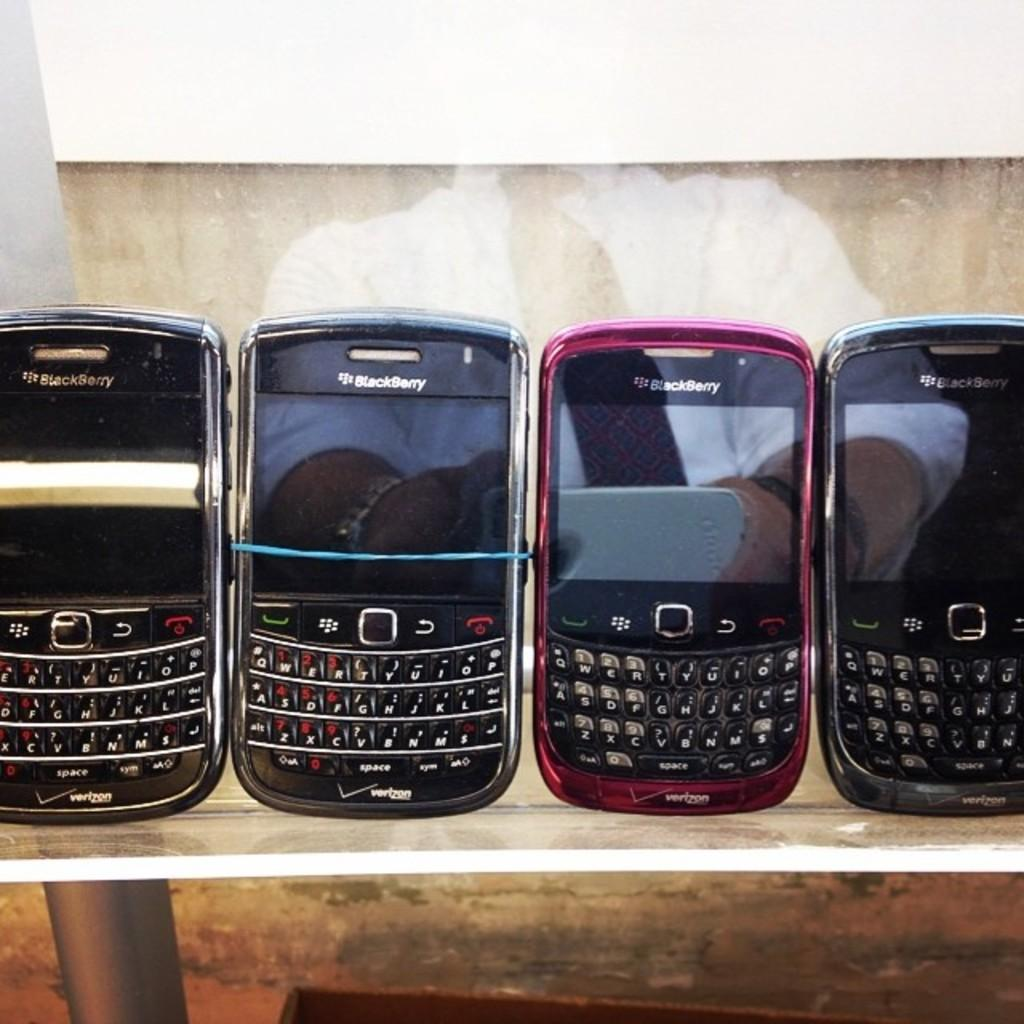Provide a one-sentence caption for the provided image. A row of Blackberry phones that say Verizon are on a shelf. 